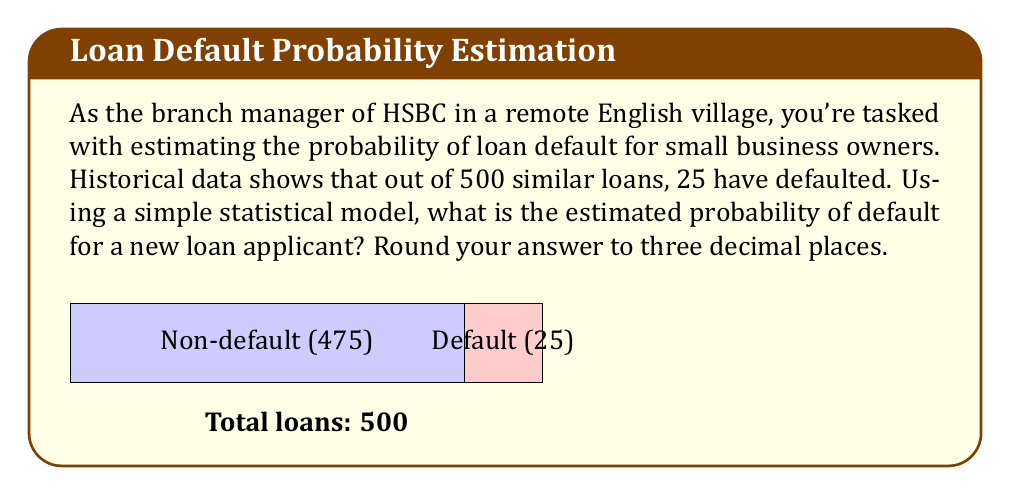Show me your answer to this math problem. To estimate the probability of loan default using a simple statistical model, we can use the relative frequency approach:

1) First, let's identify our data:
   - Total number of loans: $n = 500$
   - Number of defaulted loans: $x = 25$

2) The probability of an event is estimated by its relative frequency:

   $$P(\text{default}) = \frac{\text{number of favorable outcomes}}{\text{total number of possible outcomes}}$$

3) In this case:

   $$P(\text{default}) = \frac{x}{n} = \frac{25}{500}$$

4) Simplify the fraction:

   $$P(\text{default}) = \frac{1}{20} = 0.05$$

5) Round to three decimal places:

   $$P(\text{default}) \approx 0.050$$

This simple model assumes that past performance is indicative of future results and that the loans in the historical data are representative of new loan applicants. In practice, more sophisticated models incorporating multiple factors would likely be used for more accurate predictions.
Answer: 0.050 